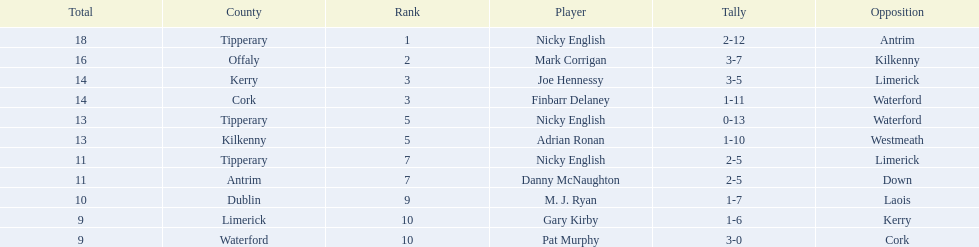Who are all the players? Nicky English, Mark Corrigan, Joe Hennessy, Finbarr Delaney, Nicky English, Adrian Ronan, Nicky English, Danny McNaughton, M. J. Ryan, Gary Kirby, Pat Murphy. How many points did they receive? 18, 16, 14, 14, 13, 13, 11, 11, 10, 9, 9. And which player received 10 points? M. J. Ryan. 